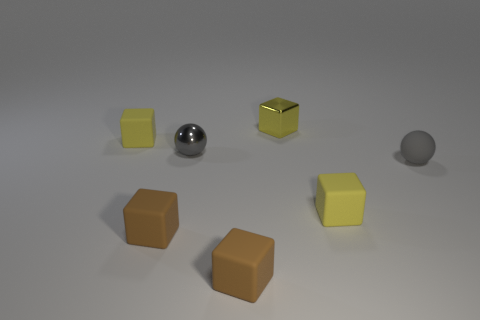What is the shape of the tiny thing that is the same color as the small metallic sphere?
Keep it short and to the point. Sphere. Are there any other tiny gray objects of the same shape as the gray rubber object?
Give a very brief answer. Yes. There is a gray rubber object that is the same size as the yellow metallic object; what is its shape?
Provide a succinct answer. Sphere. There is a metallic sphere; is it the same color as the ball to the right of the tiny metal cube?
Keep it short and to the point. Yes. There is a small brown rubber block on the left side of the small metal ball; how many small things are in front of it?
Ensure brevity in your answer.  1. What size is the thing that is on the left side of the small gray metal sphere and in front of the small gray rubber sphere?
Your answer should be compact. Small. Are there any blue things of the same size as the yellow shiny thing?
Your answer should be compact. No. Is the number of shiny blocks that are left of the gray rubber sphere greater than the number of tiny metal blocks to the left of the tiny yellow shiny cube?
Offer a very short reply. Yes. How many tiny objects are on the left side of the yellow matte object that is to the right of the tiny gray ball left of the small metallic block?
Your response must be concise. 5. Do the gray metal thing and the tiny gray object on the right side of the yellow metal cube have the same shape?
Your response must be concise. Yes. 